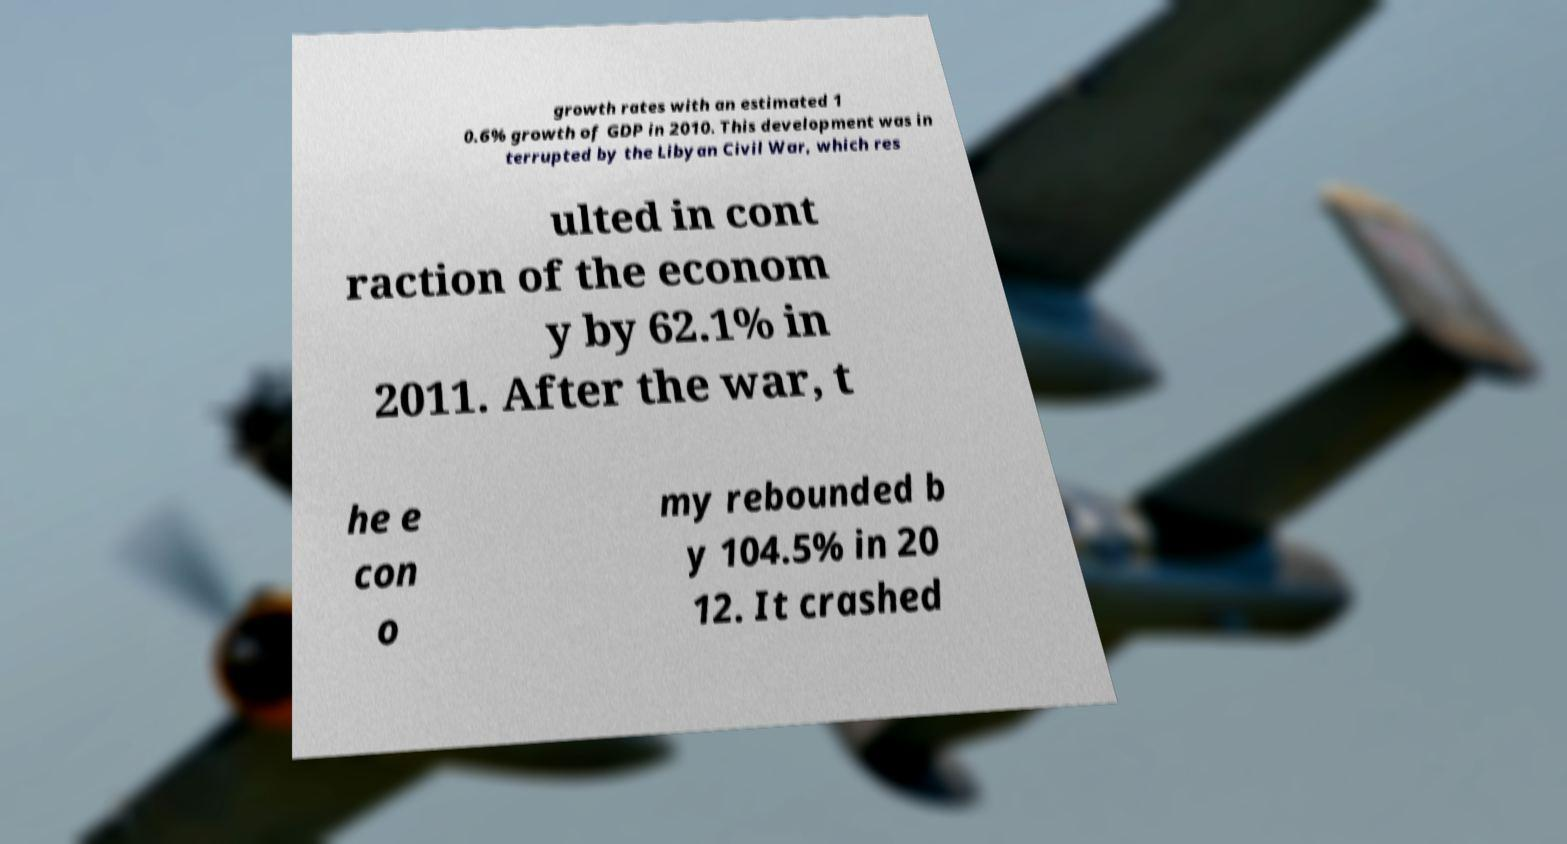Please read and relay the text visible in this image. What does it say? growth rates with an estimated 1 0.6% growth of GDP in 2010. This development was in terrupted by the Libyan Civil War, which res ulted in cont raction of the econom y by 62.1% in 2011. After the war, t he e con o my rebounded b y 104.5% in 20 12. It crashed 